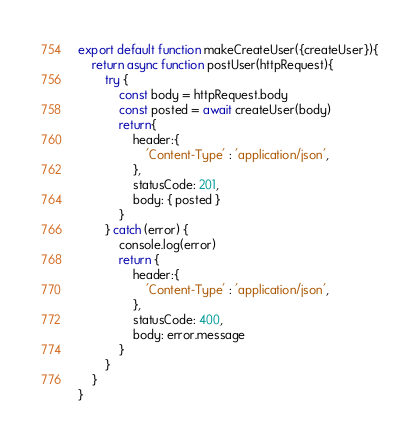<code> <loc_0><loc_0><loc_500><loc_500><_JavaScript_>export default function makeCreateUser({createUser}){
    return async function postUser(httpRequest){
        try {
            const body = httpRequest.body
            const posted = await createUser(body)
            return{
                header:{
                    'Content-Type' : 'application/json',
                },
                statusCode: 201,
                body: { posted }
            }
        } catch (error) {
            console.log(error)
            return {
                header:{
                    'Content-Type' : 'application/json',
                },
                statusCode: 400,
                body: error.message
            }
        }
    }
}</code> 